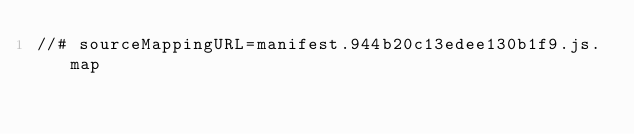Convert code to text. <code><loc_0><loc_0><loc_500><loc_500><_JavaScript_>//# sourceMappingURL=manifest.944b20c13edee130b1f9.js.map</code> 